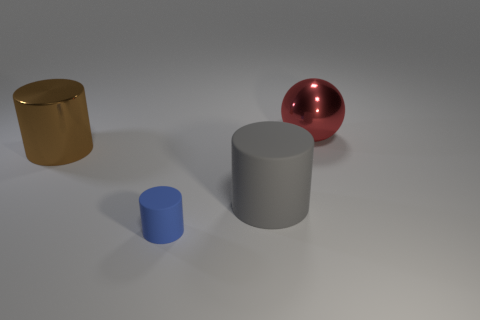Is there any other thing that has the same size as the blue thing?
Make the answer very short. No. How many things are big metallic things or large brown matte balls?
Your answer should be compact. 2. What number of other things are the same shape as the big red thing?
Ensure brevity in your answer.  0. Does the big object in front of the brown shiny object have the same material as the object in front of the gray matte cylinder?
Your response must be concise. Yes. What shape is the thing that is behind the large rubber cylinder and right of the small cylinder?
Your response must be concise. Sphere. The large object that is both right of the brown cylinder and in front of the large red metal thing is made of what material?
Ensure brevity in your answer.  Rubber. The big red thing that is the same material as the large brown cylinder is what shape?
Offer a terse response. Sphere. Is there anything else that has the same color as the tiny matte thing?
Ensure brevity in your answer.  No. Are there more big gray rubber cylinders to the right of the brown object than tiny metal objects?
Provide a succinct answer. Yes. What material is the brown cylinder?
Keep it short and to the point. Metal. 